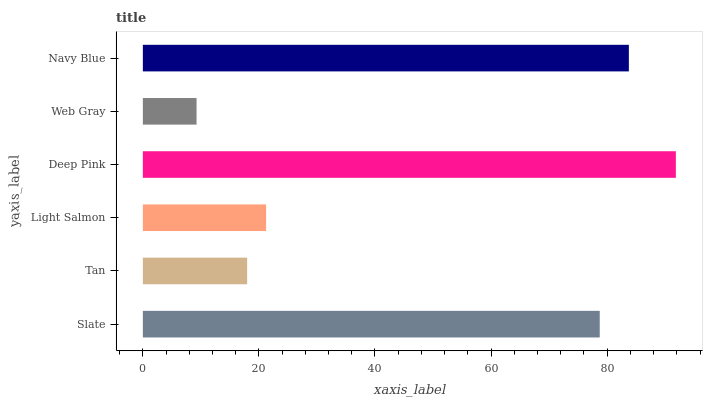Is Web Gray the minimum?
Answer yes or no. Yes. Is Deep Pink the maximum?
Answer yes or no. Yes. Is Tan the minimum?
Answer yes or no. No. Is Tan the maximum?
Answer yes or no. No. Is Slate greater than Tan?
Answer yes or no. Yes. Is Tan less than Slate?
Answer yes or no. Yes. Is Tan greater than Slate?
Answer yes or no. No. Is Slate less than Tan?
Answer yes or no. No. Is Slate the high median?
Answer yes or no. Yes. Is Light Salmon the low median?
Answer yes or no. Yes. Is Deep Pink the high median?
Answer yes or no. No. Is Slate the low median?
Answer yes or no. No. 